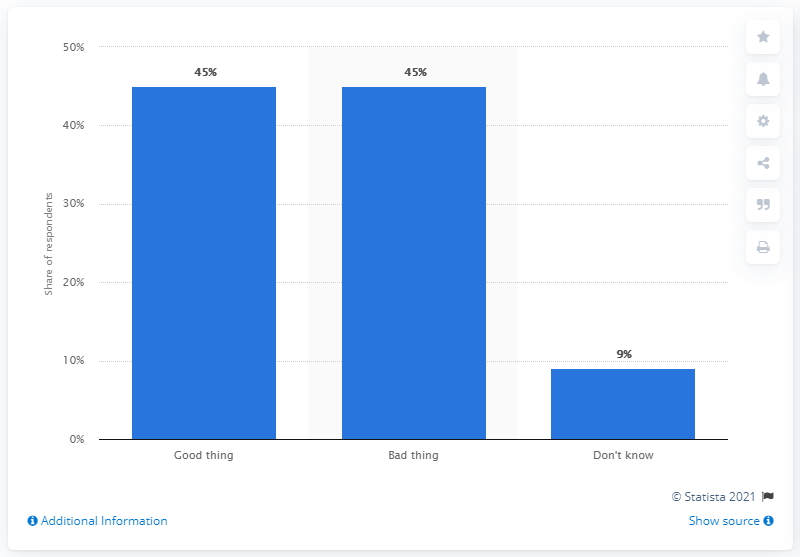Draw attention to some important aspects in this diagram. The mode of the bar values is 45. The ratio of the most opinion to the least opinion is 5 to 1. 